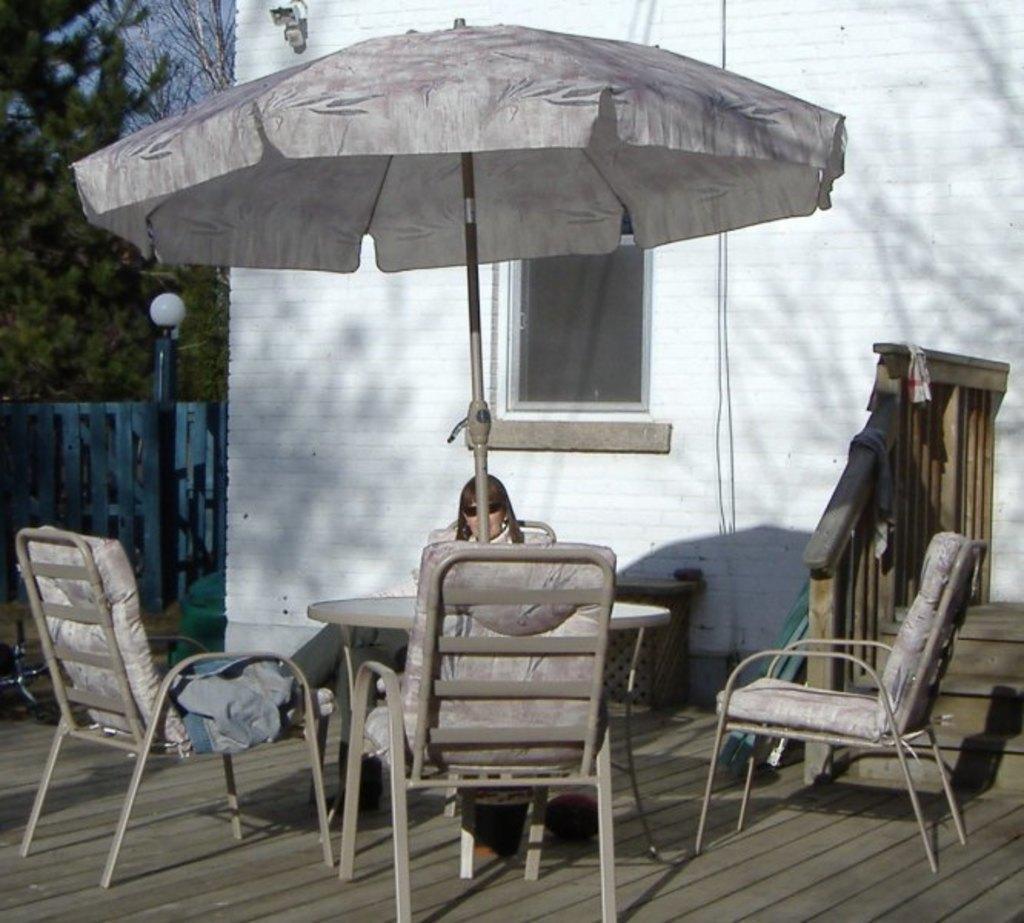Could you give a brief overview of what you see in this image? In the image in the center there is a building,wall,window,pole,fence,staircase,tent,table,chairs and one person sitting. In the background we can see the sky and trees. 